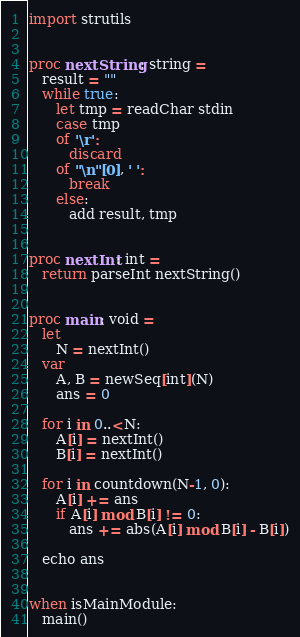<code> <loc_0><loc_0><loc_500><loc_500><_Nim_>import strutils


proc nextString: string =
   result = ""
   while true:
      let tmp = readChar stdin
      case tmp
      of '\r':
         discard
      of "\n"[0], ' ':
         break
      else:
         add result, tmp


proc nextInt: int =
   return parseInt nextString()


proc main: void =
   let
      N = nextInt()
   var
      A, B = newSeq[int](N)
      ans = 0

   for i in 0..<N:
      A[i] = nextInt()
      B[i] = nextInt()

   for i in countdown(N-1, 0):
      A[i] += ans
      if A[i] mod B[i] != 0:
         ans += abs(A[i] mod B[i] - B[i])

   echo ans


when isMainModule:
   main()
</code> 